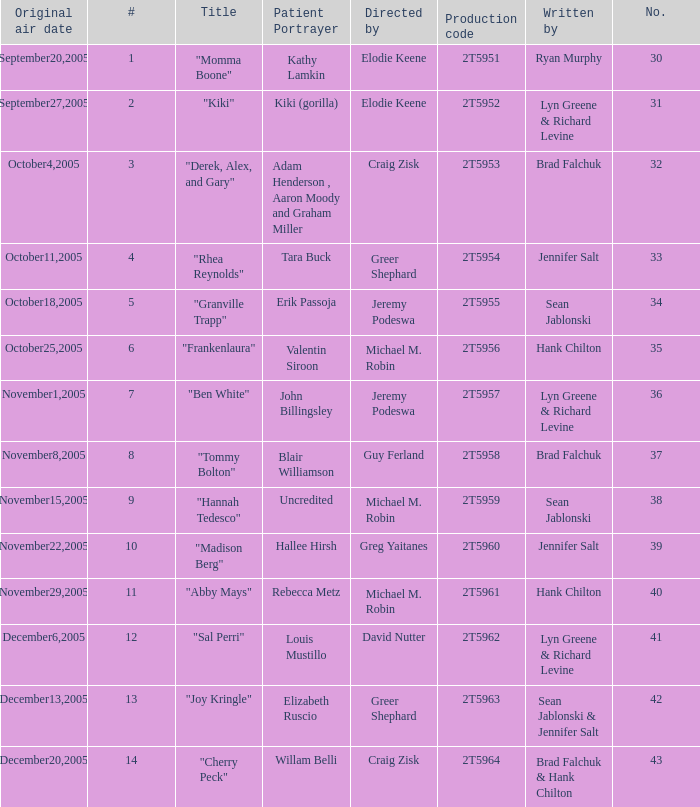Who was the writter for the  episode identified by the production code 2t5954? Jennifer Salt. 